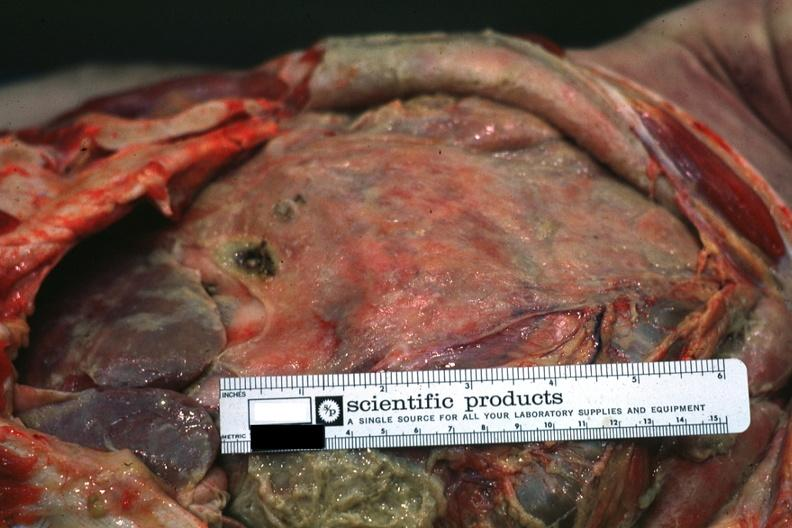what does this image show?
Answer the question using a single word or phrase. Intestines covered by fibrinopurulent membrane due to ruptured peptic ulcer 